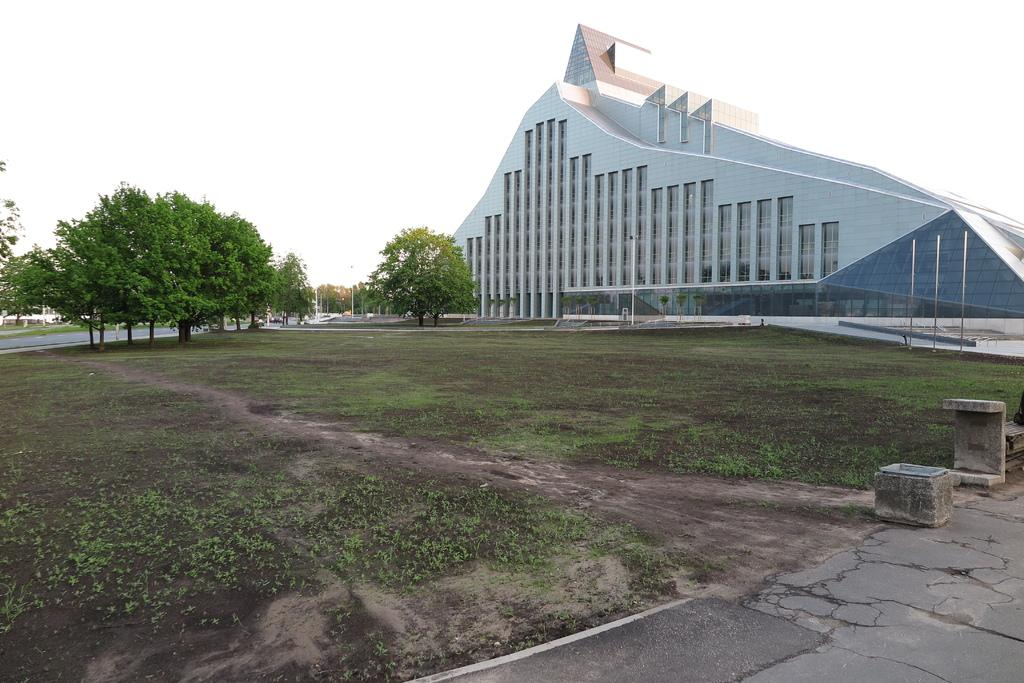What type of structure is visible in the image? There is a building in the image. What other natural elements can be seen in the image? There are trees in the image. What part of the environment is visible in the image? The sky and the ground are visible in the image. Can you describe the floor in the image? There is a floor in the image. What architectural feature is present in the image? There is a pole in the image. What type of water feature can be seen in the image? Fountains are present in the image. Where are the rabbits playing in the image? There are no rabbits present in the image. What type of vacation is being depicted in the image? The image does not depict a vacation; it shows a building, trees, sky, ground, floor, pole, and fountains. 